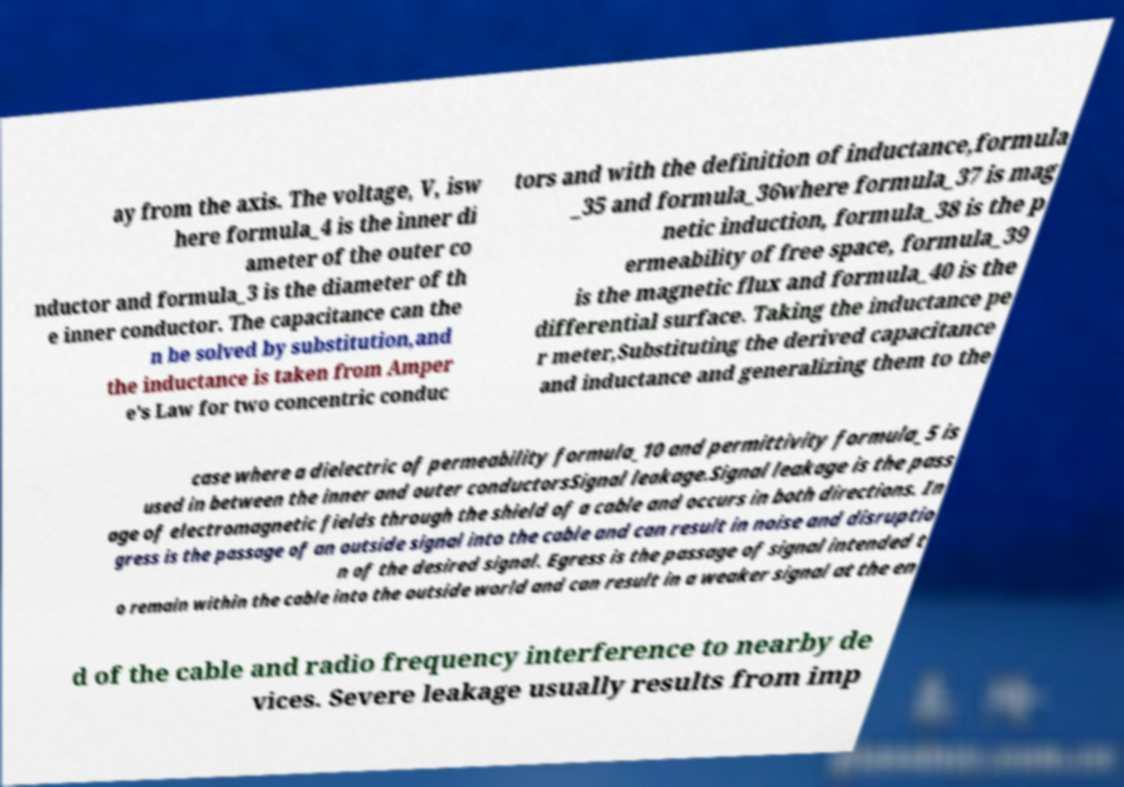Please identify and transcribe the text found in this image. ay from the axis. The voltage, V, isw here formula_4 is the inner di ameter of the outer co nductor and formula_3 is the diameter of th e inner conductor. The capacitance can the n be solved by substitution,and the inductance is taken from Amper e's Law for two concentric conduc tors and with the definition of inductance,formula _35 and formula_36where formula_37 is mag netic induction, formula_38 is the p ermeability of free space, formula_39 is the magnetic flux and formula_40 is the differential surface. Taking the inductance pe r meter,Substituting the derived capacitance and inductance and generalizing them to the case where a dielectric of permeability formula_10 and permittivity formula_5 is used in between the inner and outer conductorsSignal leakage.Signal leakage is the pass age of electromagnetic fields through the shield of a cable and occurs in both directions. In gress is the passage of an outside signal into the cable and can result in noise and disruptio n of the desired signal. Egress is the passage of signal intended t o remain within the cable into the outside world and can result in a weaker signal at the en d of the cable and radio frequency interference to nearby de vices. Severe leakage usually results from imp 